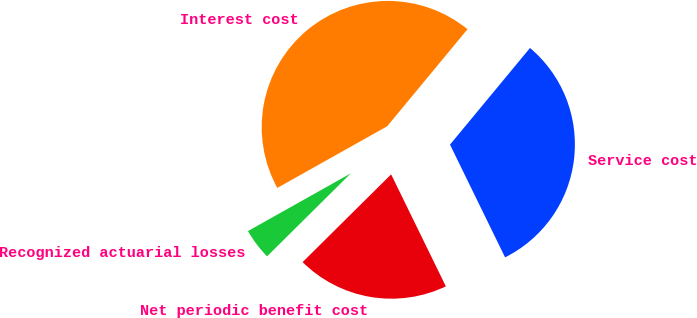<chart> <loc_0><loc_0><loc_500><loc_500><pie_chart><fcel>Service cost<fcel>Interest cost<fcel>Recognized actuarial losses<fcel>Net periodic benefit cost<nl><fcel>31.76%<fcel>44.14%<fcel>4.29%<fcel>19.8%<nl></chart> 